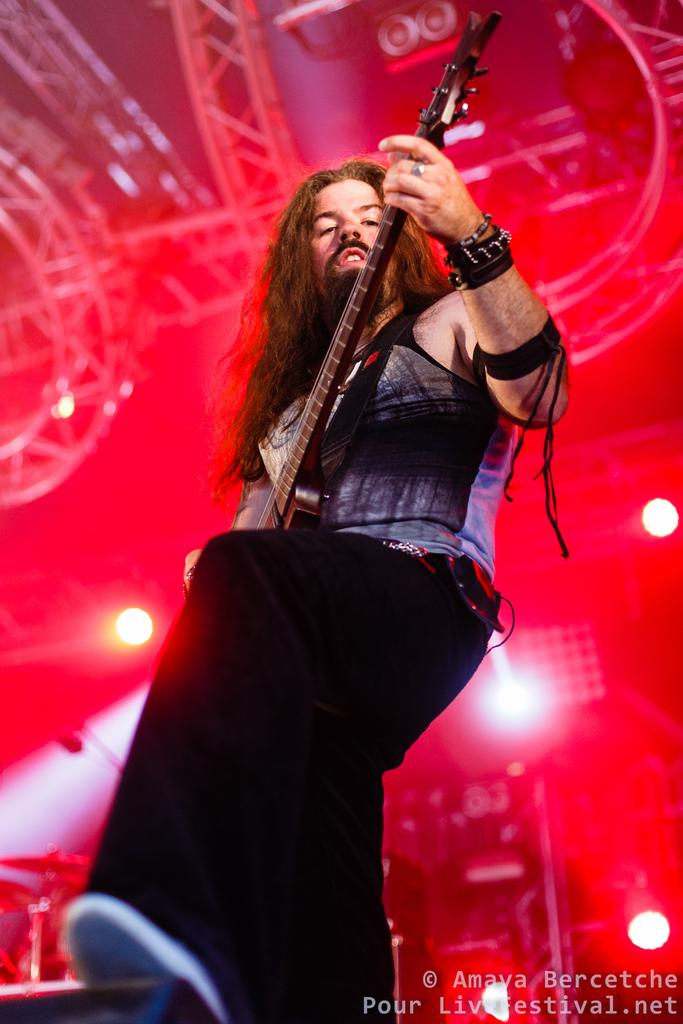What is the person in the image doing? The person is playing the guitar in the image. What else can be seen in the image besides the person playing the guitar? There are lights visible in the image, as well as drums. What part of a building can be seen in the image? The roof is visible in the image. What type of table is being used by the expert to play the guitar in the image? There is no table mentioned in the image, nor is there any indication that the person playing the guitar is an expert. 